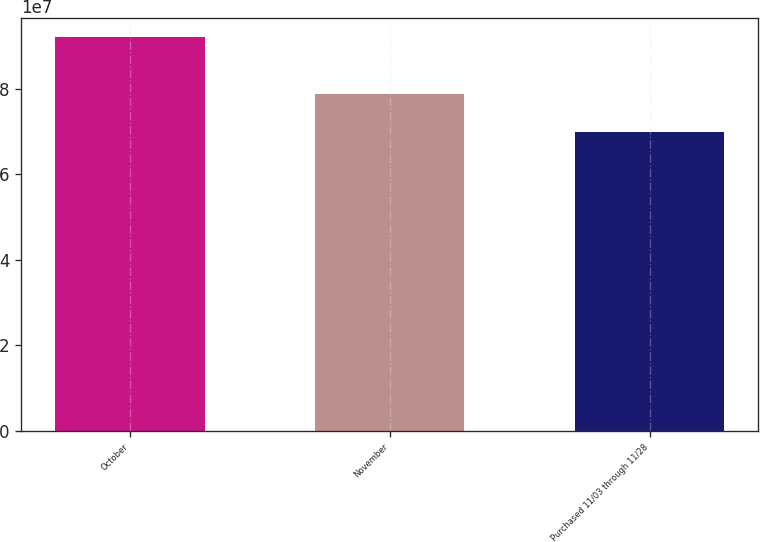<chart> <loc_0><loc_0><loc_500><loc_500><bar_chart><fcel>October<fcel>November<fcel>Purchased 11/03 through 11/28<nl><fcel>9.20352e+07<fcel>7.86432e+07<fcel>6.99668e+07<nl></chart> 